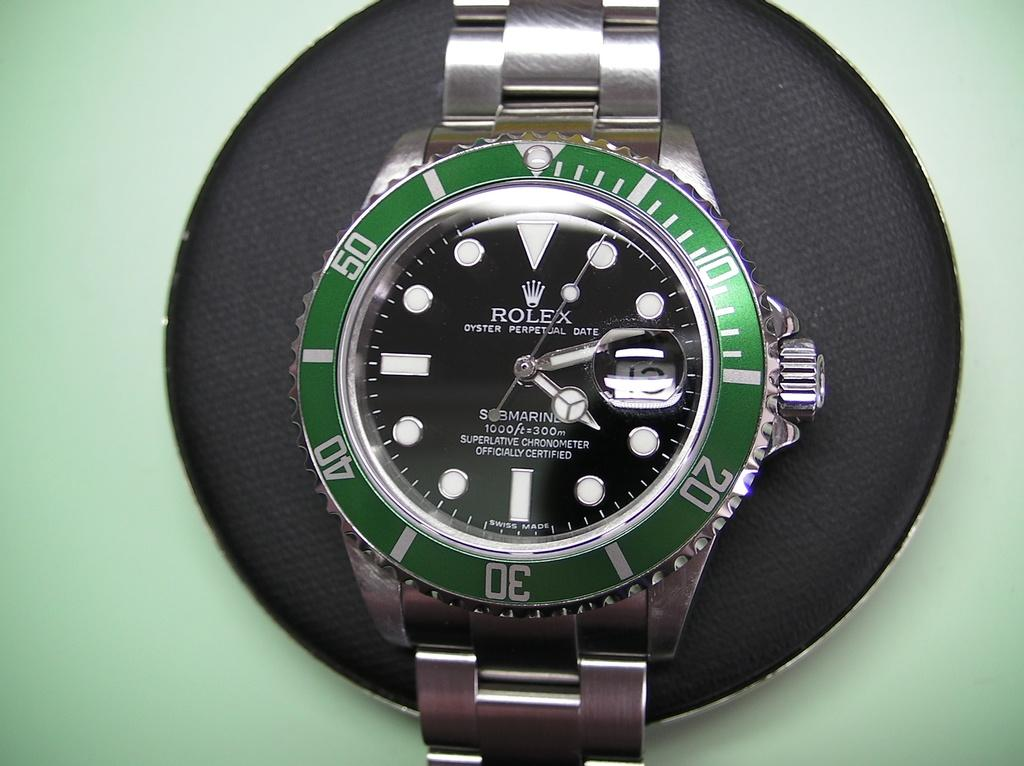<image>
Write a terse but informative summary of the picture. A Rolex brand watch with a green circle around the face of it. 